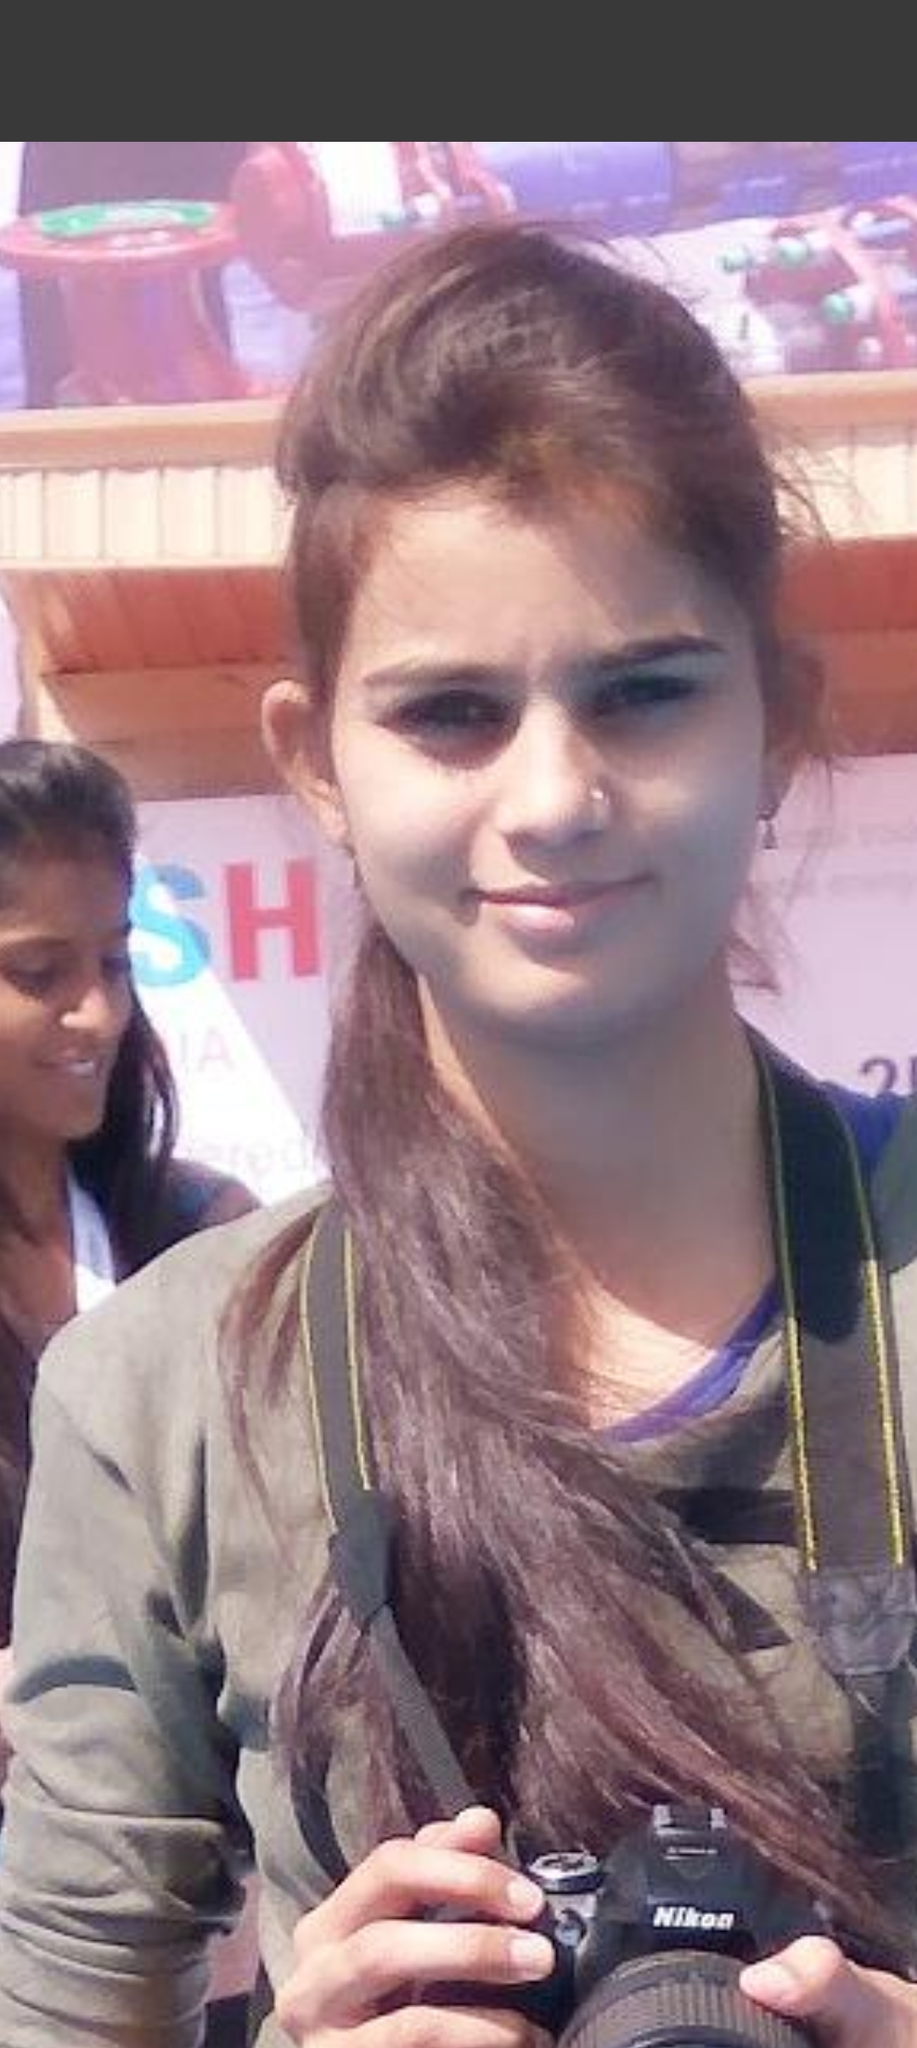BEUTIFUL WHITE DRESS The girl is wearing a beautiful white dress. She has long brown hair and brown eyes. She is smiling and holding a camera. She is standing in front of a colorful background. 